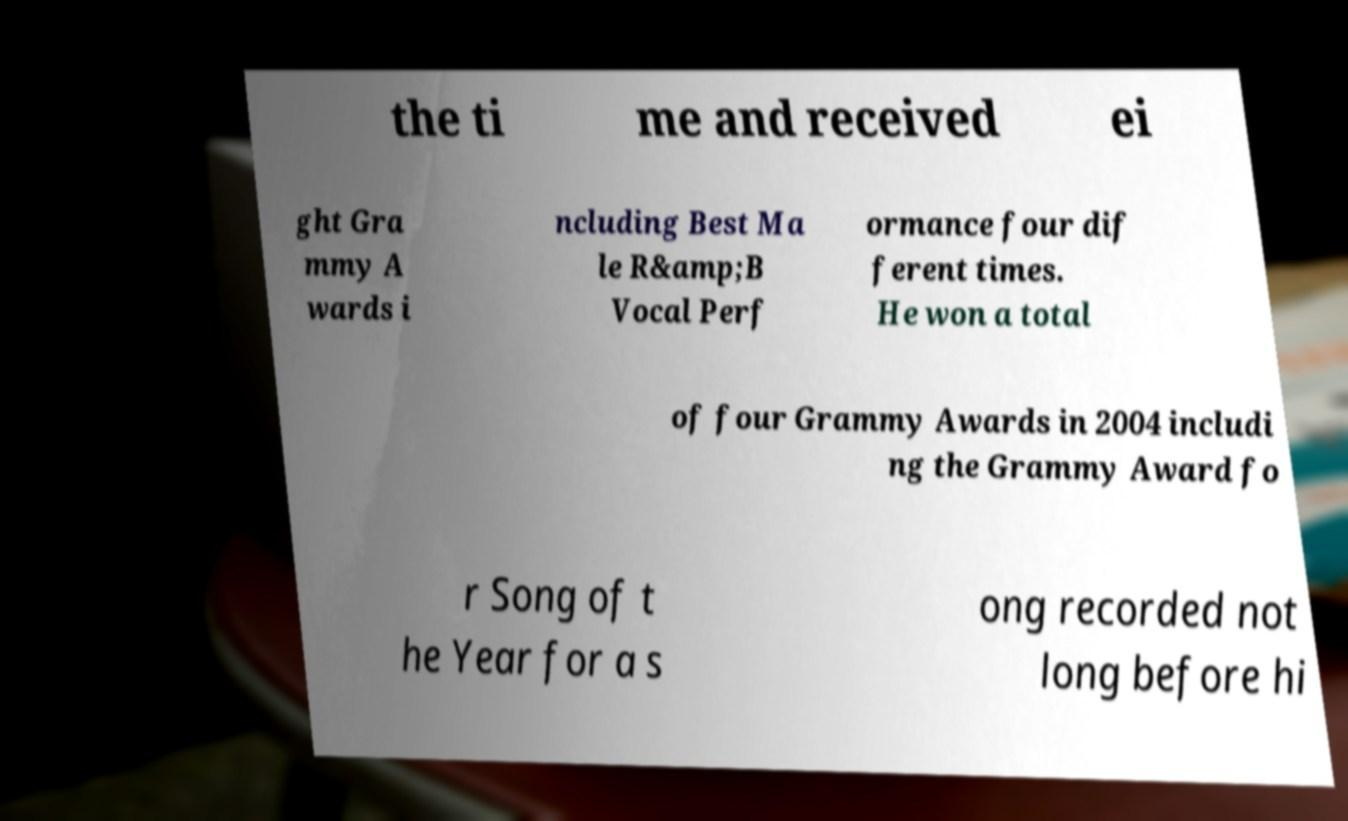Can you accurately transcribe the text from the provided image for me? the ti me and received ei ght Gra mmy A wards i ncluding Best Ma le R&amp;B Vocal Perf ormance four dif ferent times. He won a total of four Grammy Awards in 2004 includi ng the Grammy Award fo r Song of t he Year for a s ong recorded not long before hi 